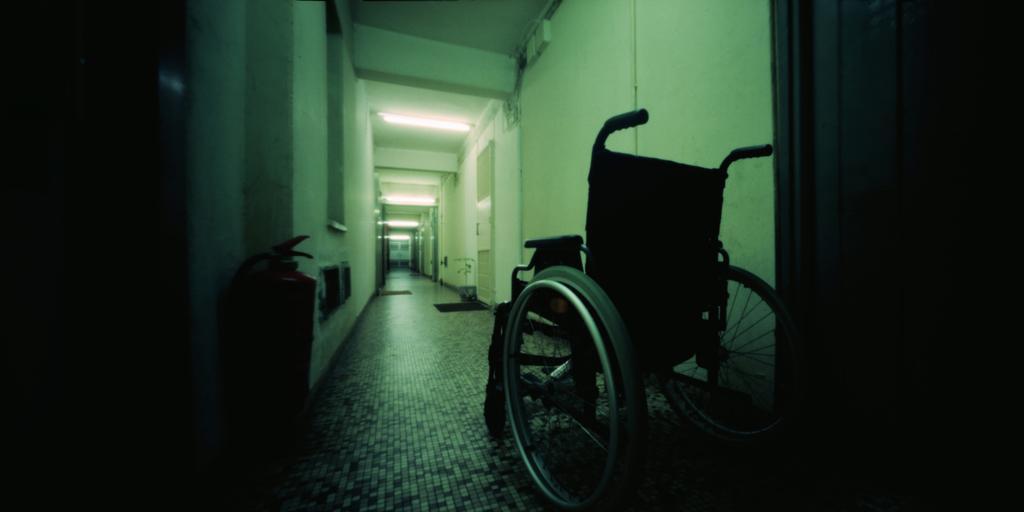Describe this image in one or two sentences. In this image, we can see an inside view of a building. There is a wheelchair in the bottom left of the image. There are lights in the middle of the image. 